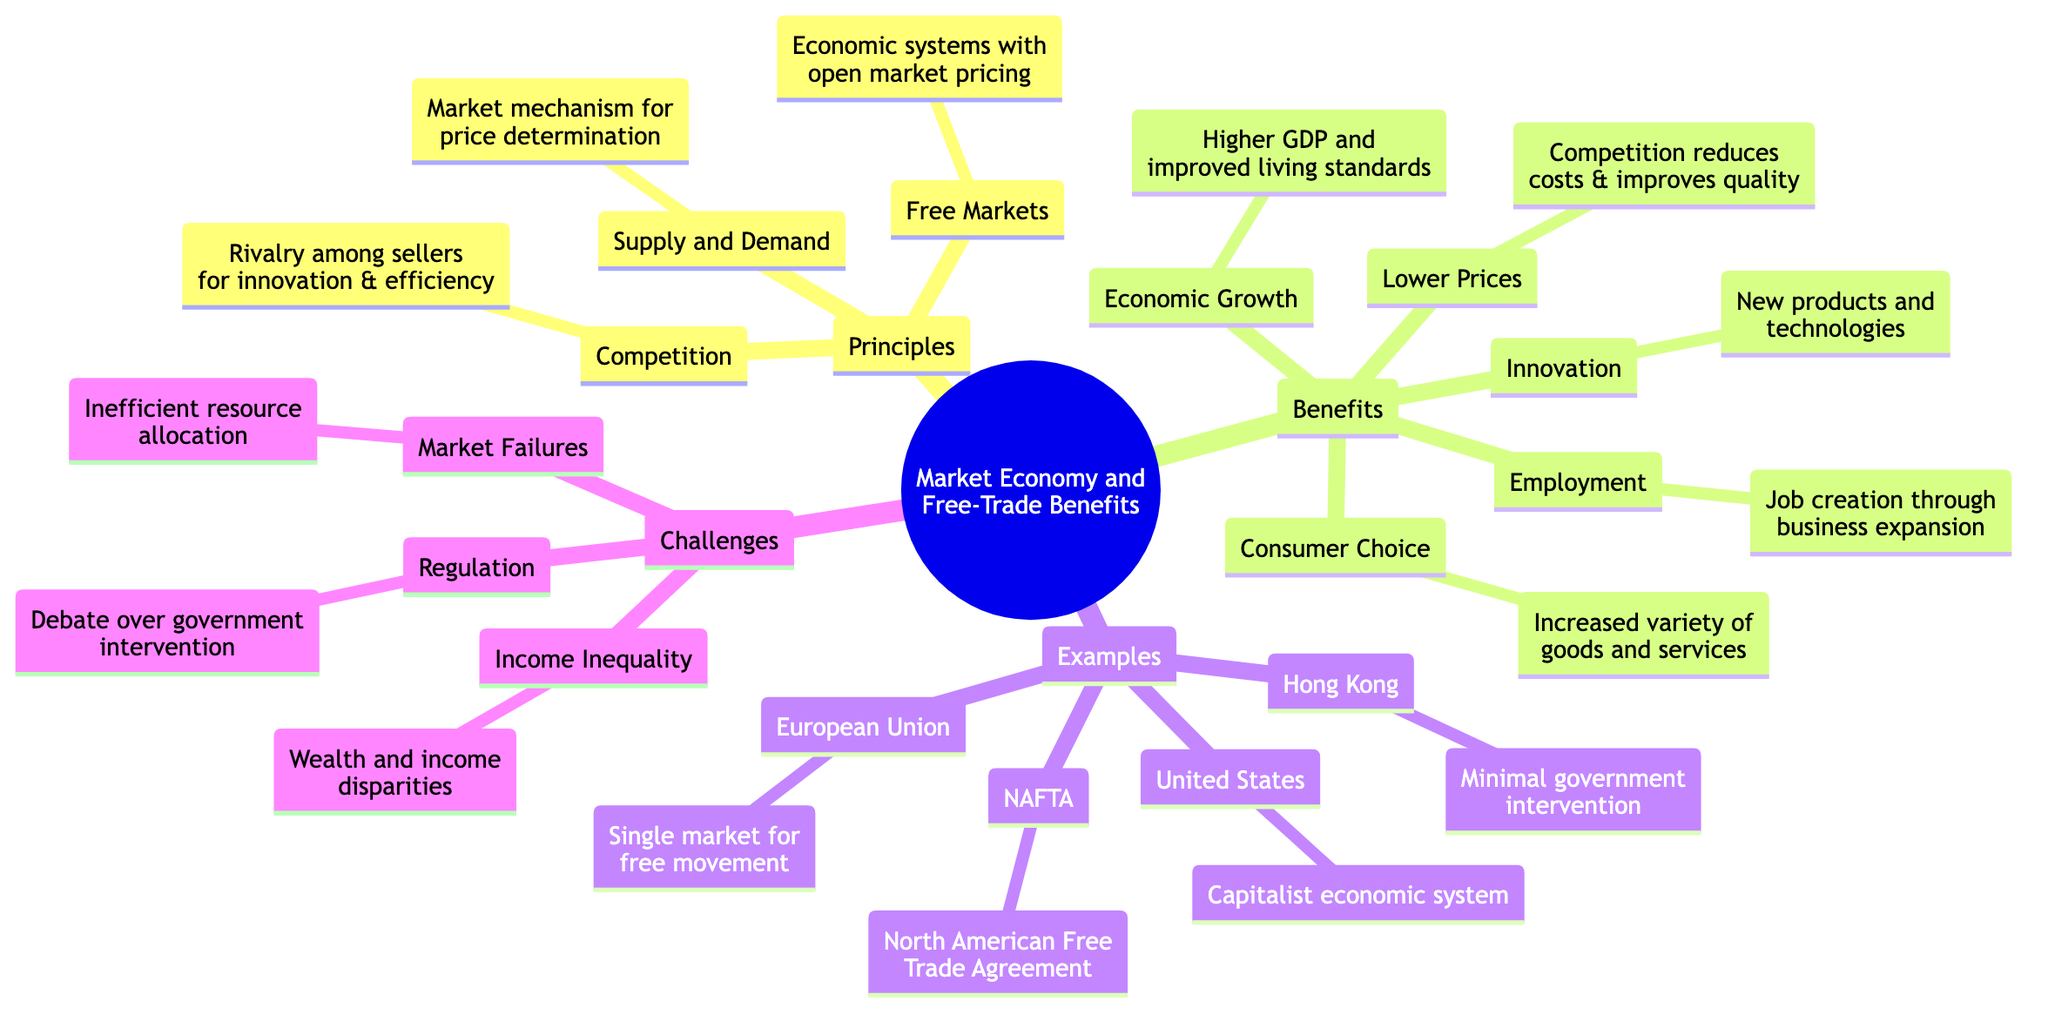What are the principles of a market economy? The diagram lists three principles under the "Principles" category: Free Markets, Competition, and Supply and Demand.
Answer: Free Markets, Competition, Supply and Demand How many benefits are listed in the concept map? Under the "Benefits" section, there are five items mentioned: Consumer Choice, Lower Prices, Innovation, Economic Growth, and Employment. Therefore, the total count is five.
Answer: 5 What is an example of a free market economy? The examples section lists Hong Kong as an instance of a free market economy characterized by minimal government intervention.
Answer: Hong Kong Which challenge relates to market economies causing disparities? The diagram identifies Income Inequality as a challenge that refers to the significant disparities in wealth and income resulting from market economies.
Answer: Income Inequality What is the relationship between competition and innovation? According to the diagram, Competition leads to Innovation; it states that rivalry among sellers encourages innovation, resulting in new products and technologies.
Answer: Competition encourages innovation How does economic growth relate to free trade? The "Economic Growth" benefit mentions that free trade leads to higher GDP and improved living standards. Thus, free trade is positively associated with economic growth.
Answer: Higher GDP and improved living standards What are the two issues listed under Regulation? The challenges section includes Regulation as a topic, highlighting the debate over the need for government intervention to correct market failures versus maintaining economic freedom. Therefore, two issues are: government intervention and economic freedom.
Answer: Government intervention and economic freedom What does the United States exemplify in the diagram? In the "Examples" section, the United States is marked as representative of a capitalist economic system where market forces largely dictate the economy.
Answer: Capitalist economic system 